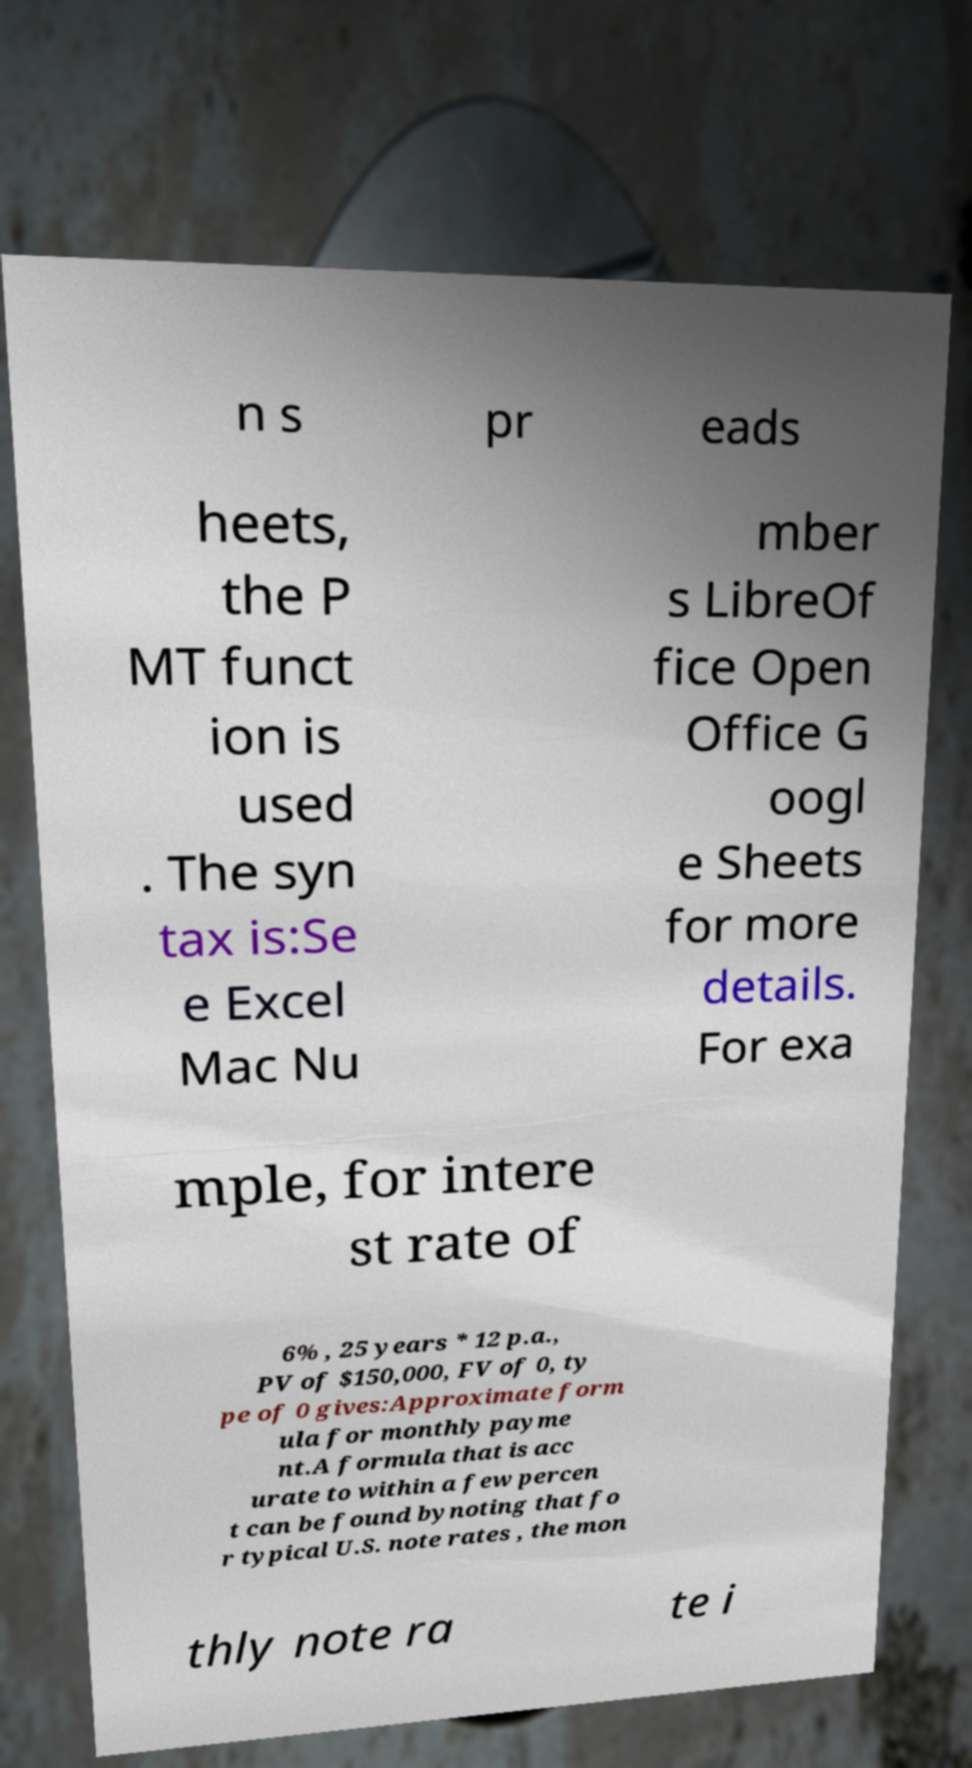Can you read and provide the text displayed in the image?This photo seems to have some interesting text. Can you extract and type it out for me? n s pr eads heets, the P MT funct ion is used . The syn tax is:Se e Excel Mac Nu mber s LibreOf fice Open Office G oogl e Sheets for more details. For exa mple, for intere st rate of 6% , 25 years * 12 p.a., PV of $150,000, FV of 0, ty pe of 0 gives:Approximate form ula for monthly payme nt.A formula that is acc urate to within a few percen t can be found bynoting that fo r typical U.S. note rates , the mon thly note ra te i 